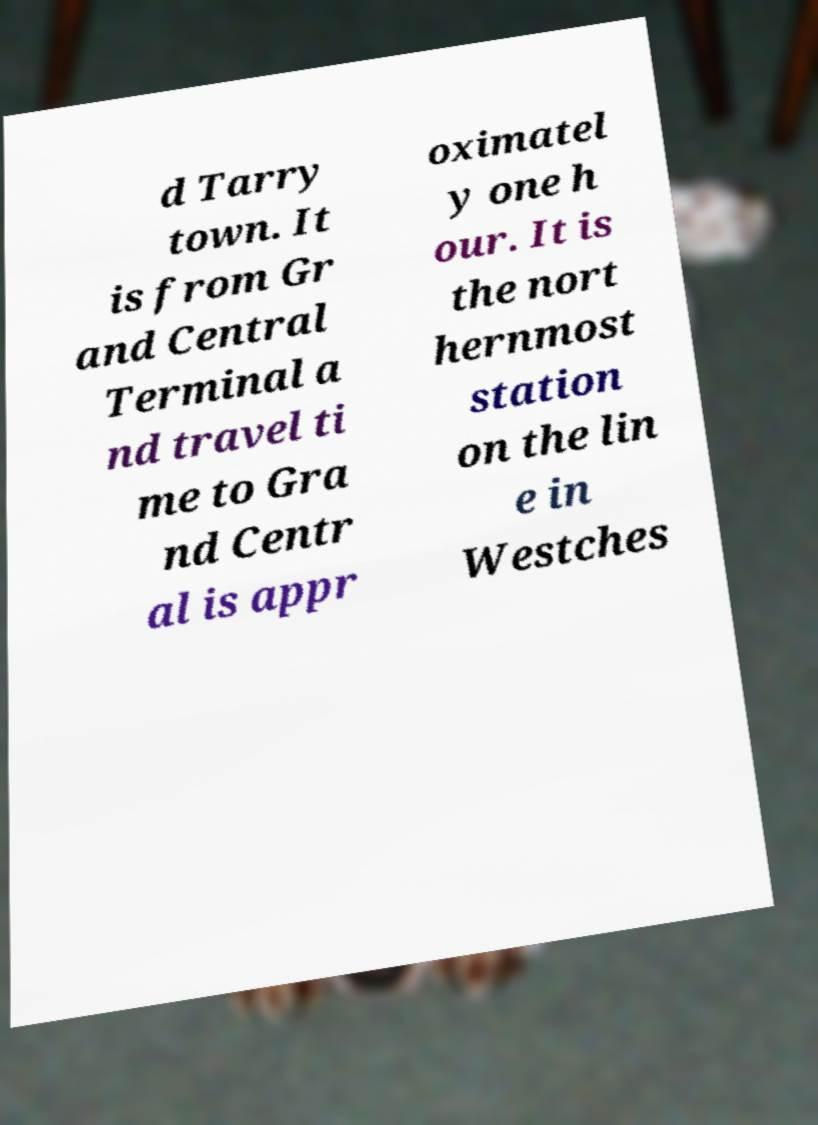Please identify and transcribe the text found in this image. d Tarry town. It is from Gr and Central Terminal a nd travel ti me to Gra nd Centr al is appr oximatel y one h our. It is the nort hernmost station on the lin e in Westches 